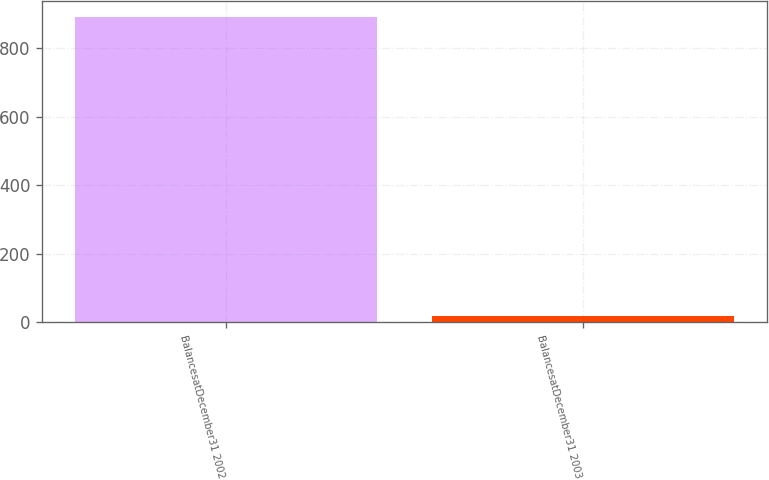Convert chart. <chart><loc_0><loc_0><loc_500><loc_500><bar_chart><fcel>BalancesatDecember31 2002<fcel>BalancesatDecember31 2003<nl><fcel>892<fcel>17<nl></chart> 